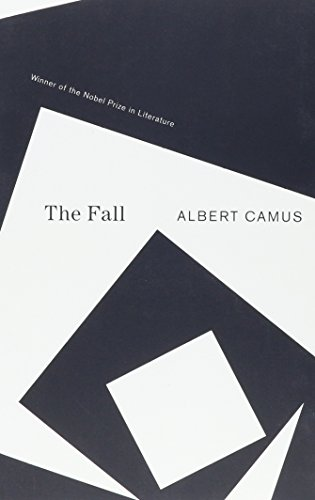What type of book is this? This book belongs to the 'Literature & Fiction' genre, particularly known for its deep philosophical insights and exploration of complex human emotions. 